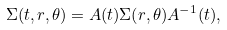Convert formula to latex. <formula><loc_0><loc_0><loc_500><loc_500>\Sigma ( t , r , \theta ) = A ( t ) \Sigma ( r , \theta ) A ^ { - 1 } ( t ) ,</formula> 